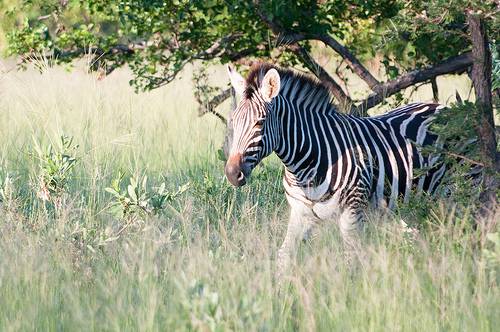Please provide a short description for this region: [0.04, 0.43, 0.16, 0.56]. In this region, marked by the coordinates [0.04, 0.43, 0.16, 0.56], there is a small green plant growing in the grass. This plant adds a touch of vibrant green to the scene. 